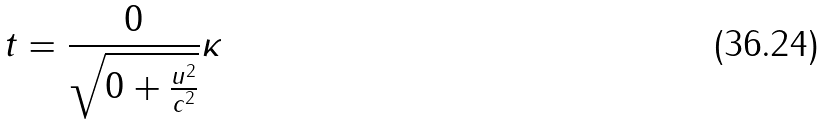Convert formula to latex. <formula><loc_0><loc_0><loc_500><loc_500>t = \frac { 0 } { \sqrt { 0 + \frac { u ^ { 2 } } { c ^ { 2 } } } } \kappa</formula> 